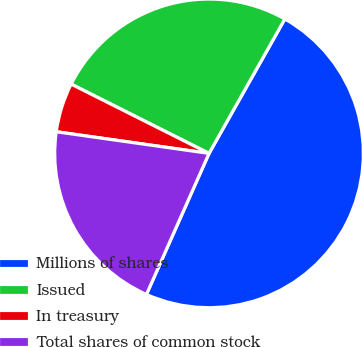<chart> <loc_0><loc_0><loc_500><loc_500><pie_chart><fcel>Millions of shares<fcel>Issued<fcel>In treasury<fcel>Total shares of common stock<nl><fcel>48.47%<fcel>25.76%<fcel>5.17%<fcel>20.59%<nl></chart> 